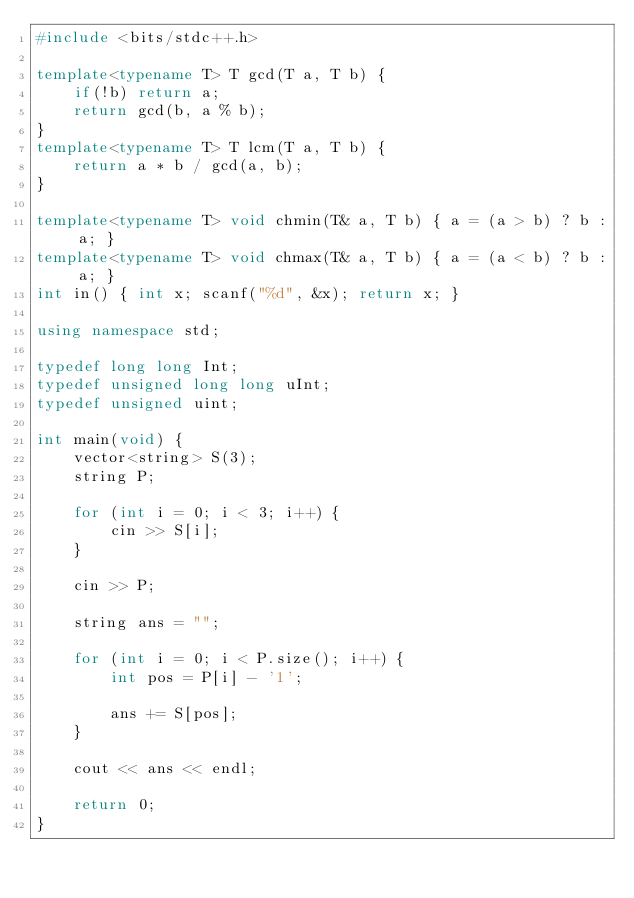<code> <loc_0><loc_0><loc_500><loc_500><_C++_>#include <bits/stdc++.h>

template<typename T> T gcd(T a, T b) {
    if(!b) return a;
    return gcd(b, a % b);
}
template<typename T> T lcm(T a, T b) {
    return a * b / gcd(a, b);
}

template<typename T> void chmin(T& a, T b) { a = (a > b) ? b : a; }
template<typename T> void chmax(T& a, T b) { a = (a < b) ? b : a; }
int in() { int x; scanf("%d", &x); return x; }

using namespace std;

typedef long long Int;
typedef unsigned long long uInt;
typedef unsigned uint;

int main(void) {
    vector<string> S(3);
    string P;

    for (int i = 0; i < 3; i++) {
        cin >> S[i];
    }

    cin >> P;

    string ans = "";

    for (int i = 0; i < P.size(); i++) {
        int pos = P[i] - '1';

        ans += S[pos];
    }

    cout << ans << endl;

    return 0;
}
</code> 